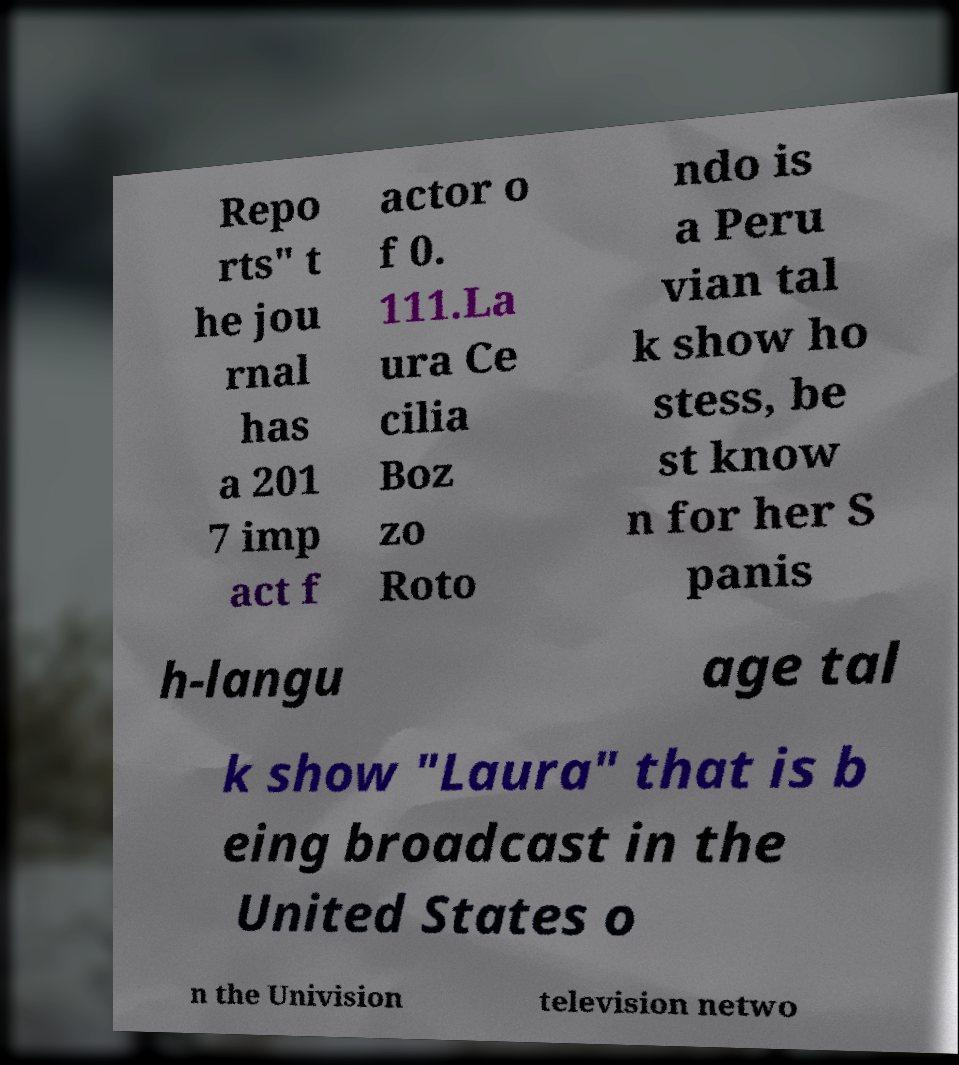What messages or text are displayed in this image? I need them in a readable, typed format. Repo rts" t he jou rnal has a 201 7 imp act f actor o f 0. 111.La ura Ce cilia Boz zo Roto ndo is a Peru vian tal k show ho stess, be st know n for her S panis h-langu age tal k show "Laura" that is b eing broadcast in the United States o n the Univision television netwo 